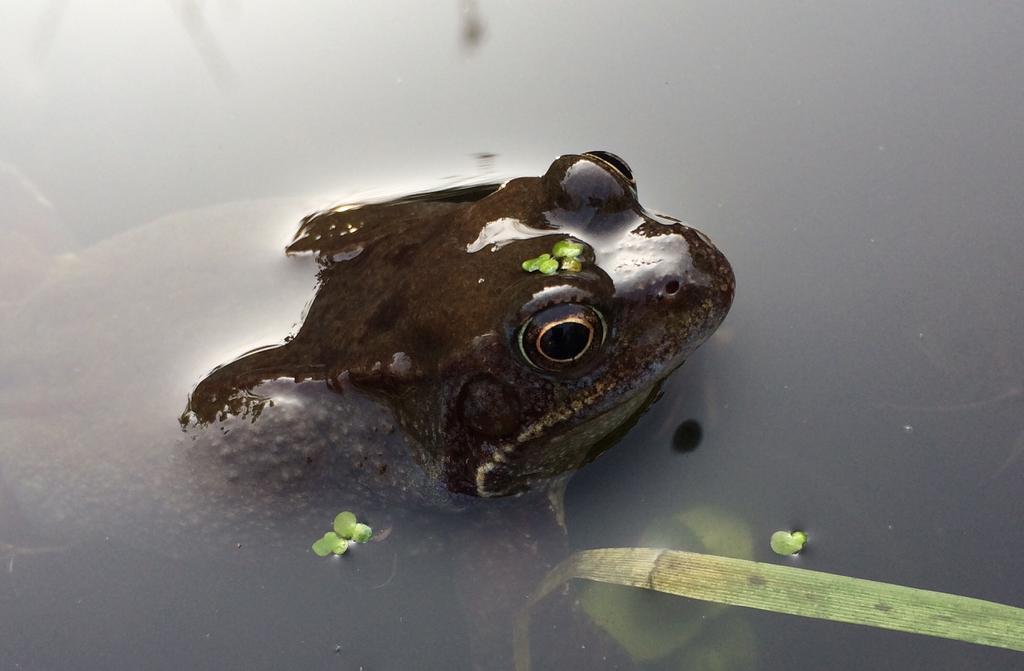Could you give a brief overview of what you see in this image? In this picture there is water, in the water there is a frog and a water plant. 